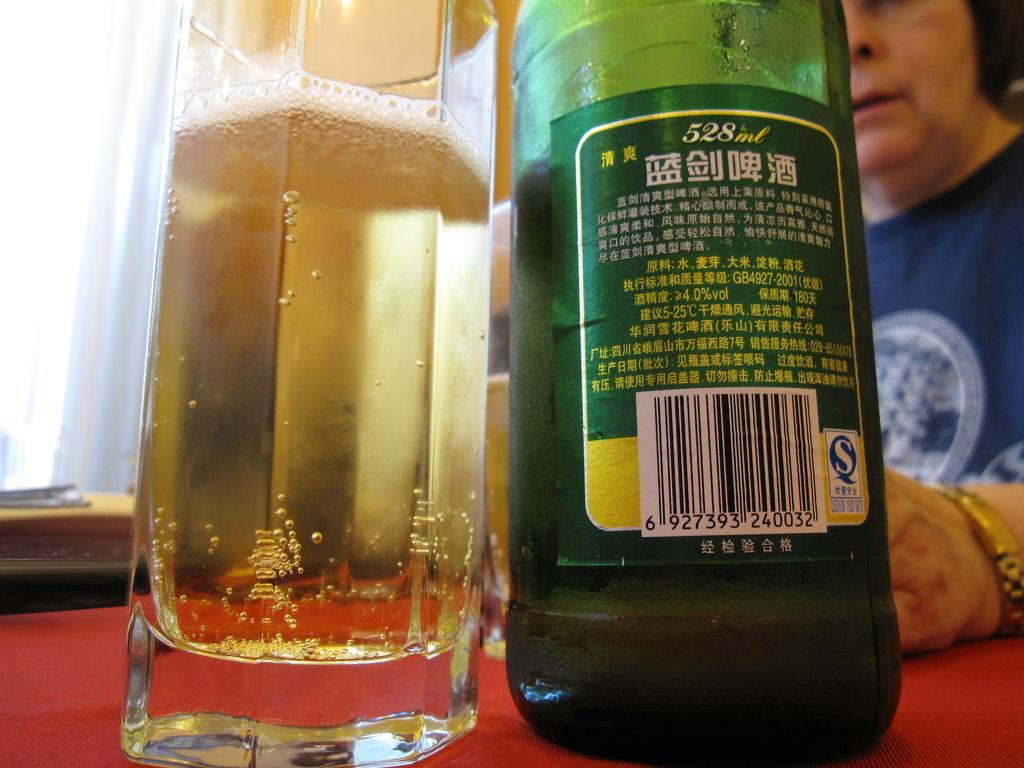<image>
Describe the image concisely. A 528ml bottle sits next to a mostly full glass. 